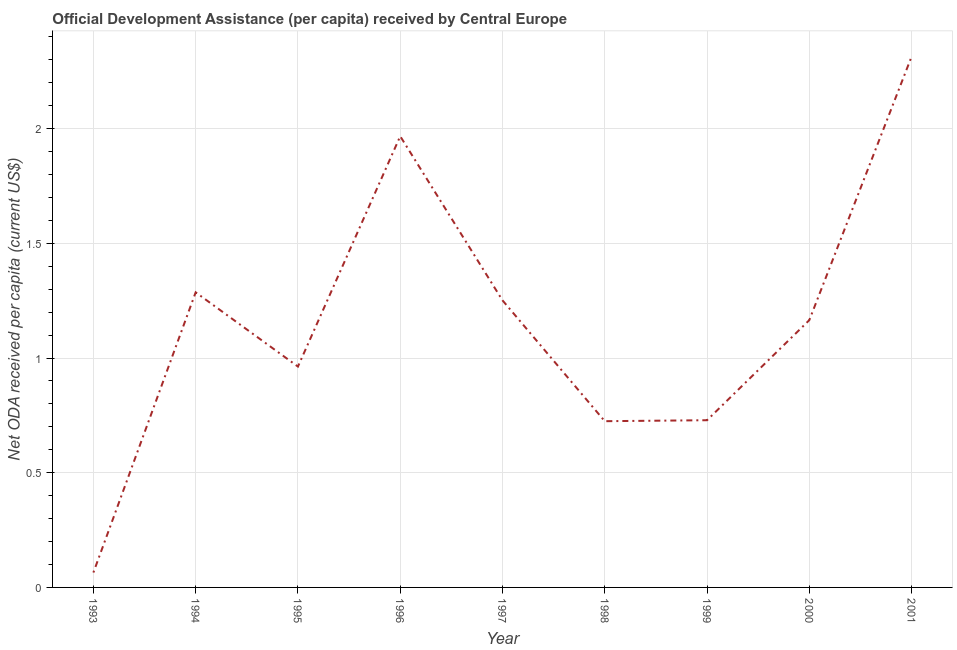What is the net oda received per capita in 2001?
Provide a short and direct response. 2.31. Across all years, what is the maximum net oda received per capita?
Offer a very short reply. 2.31. Across all years, what is the minimum net oda received per capita?
Provide a short and direct response. 0.06. In which year was the net oda received per capita maximum?
Your response must be concise. 2001. In which year was the net oda received per capita minimum?
Provide a short and direct response. 1993. What is the sum of the net oda received per capita?
Keep it short and to the point. 10.47. What is the difference between the net oda received per capita in 1997 and 2000?
Ensure brevity in your answer.  0.09. What is the average net oda received per capita per year?
Offer a terse response. 1.16. What is the median net oda received per capita?
Offer a very short reply. 1.17. In how many years, is the net oda received per capita greater than 0.2 US$?
Provide a succinct answer. 8. What is the ratio of the net oda received per capita in 1996 to that in 1997?
Provide a short and direct response. 1.57. Is the net oda received per capita in 1994 less than that in 1995?
Keep it short and to the point. No. Is the difference between the net oda received per capita in 1996 and 1998 greater than the difference between any two years?
Give a very brief answer. No. What is the difference between the highest and the second highest net oda received per capita?
Offer a very short reply. 0.35. What is the difference between the highest and the lowest net oda received per capita?
Make the answer very short. 2.25. How many years are there in the graph?
Make the answer very short. 9. Are the values on the major ticks of Y-axis written in scientific E-notation?
Ensure brevity in your answer.  No. Does the graph contain any zero values?
Your response must be concise. No. What is the title of the graph?
Offer a terse response. Official Development Assistance (per capita) received by Central Europe. What is the label or title of the X-axis?
Make the answer very short. Year. What is the label or title of the Y-axis?
Make the answer very short. Net ODA received per capita (current US$). What is the Net ODA received per capita (current US$) in 1993?
Give a very brief answer. 0.06. What is the Net ODA received per capita (current US$) in 1994?
Offer a terse response. 1.29. What is the Net ODA received per capita (current US$) in 1995?
Your response must be concise. 0.96. What is the Net ODA received per capita (current US$) in 1996?
Give a very brief answer. 1.97. What is the Net ODA received per capita (current US$) in 1997?
Your response must be concise. 1.25. What is the Net ODA received per capita (current US$) in 1998?
Your answer should be compact. 0.72. What is the Net ODA received per capita (current US$) in 1999?
Your response must be concise. 0.73. What is the Net ODA received per capita (current US$) in 2000?
Your answer should be very brief. 1.17. What is the Net ODA received per capita (current US$) in 2001?
Your answer should be very brief. 2.31. What is the difference between the Net ODA received per capita (current US$) in 1993 and 1994?
Offer a very short reply. -1.22. What is the difference between the Net ODA received per capita (current US$) in 1993 and 1995?
Provide a succinct answer. -0.9. What is the difference between the Net ODA received per capita (current US$) in 1993 and 1996?
Give a very brief answer. -1.9. What is the difference between the Net ODA received per capita (current US$) in 1993 and 1997?
Provide a short and direct response. -1.19. What is the difference between the Net ODA received per capita (current US$) in 1993 and 1998?
Ensure brevity in your answer.  -0.66. What is the difference between the Net ODA received per capita (current US$) in 1993 and 1999?
Keep it short and to the point. -0.66. What is the difference between the Net ODA received per capita (current US$) in 1993 and 2000?
Give a very brief answer. -1.1. What is the difference between the Net ODA received per capita (current US$) in 1993 and 2001?
Offer a terse response. -2.25. What is the difference between the Net ODA received per capita (current US$) in 1994 and 1995?
Make the answer very short. 0.32. What is the difference between the Net ODA received per capita (current US$) in 1994 and 1996?
Offer a very short reply. -0.68. What is the difference between the Net ODA received per capita (current US$) in 1994 and 1997?
Your answer should be very brief. 0.03. What is the difference between the Net ODA received per capita (current US$) in 1994 and 1998?
Provide a succinct answer. 0.56. What is the difference between the Net ODA received per capita (current US$) in 1994 and 1999?
Your answer should be very brief. 0.56. What is the difference between the Net ODA received per capita (current US$) in 1994 and 2000?
Provide a succinct answer. 0.12. What is the difference between the Net ODA received per capita (current US$) in 1994 and 2001?
Offer a very short reply. -1.03. What is the difference between the Net ODA received per capita (current US$) in 1995 and 1996?
Make the answer very short. -1. What is the difference between the Net ODA received per capita (current US$) in 1995 and 1997?
Your response must be concise. -0.29. What is the difference between the Net ODA received per capita (current US$) in 1995 and 1998?
Your response must be concise. 0.24. What is the difference between the Net ODA received per capita (current US$) in 1995 and 1999?
Your response must be concise. 0.23. What is the difference between the Net ODA received per capita (current US$) in 1995 and 2000?
Offer a very short reply. -0.2. What is the difference between the Net ODA received per capita (current US$) in 1995 and 2001?
Keep it short and to the point. -1.35. What is the difference between the Net ODA received per capita (current US$) in 1996 and 1997?
Keep it short and to the point. 0.72. What is the difference between the Net ODA received per capita (current US$) in 1996 and 1998?
Provide a succinct answer. 1.24. What is the difference between the Net ODA received per capita (current US$) in 1996 and 1999?
Your answer should be compact. 1.24. What is the difference between the Net ODA received per capita (current US$) in 1996 and 2000?
Your response must be concise. 0.8. What is the difference between the Net ODA received per capita (current US$) in 1996 and 2001?
Keep it short and to the point. -0.35. What is the difference between the Net ODA received per capita (current US$) in 1997 and 1998?
Provide a short and direct response. 0.53. What is the difference between the Net ODA received per capita (current US$) in 1997 and 1999?
Provide a short and direct response. 0.52. What is the difference between the Net ODA received per capita (current US$) in 1997 and 2000?
Ensure brevity in your answer.  0.09. What is the difference between the Net ODA received per capita (current US$) in 1997 and 2001?
Provide a succinct answer. -1.06. What is the difference between the Net ODA received per capita (current US$) in 1998 and 1999?
Offer a terse response. -0. What is the difference between the Net ODA received per capita (current US$) in 1998 and 2000?
Offer a terse response. -0.44. What is the difference between the Net ODA received per capita (current US$) in 1998 and 2001?
Make the answer very short. -1.59. What is the difference between the Net ODA received per capita (current US$) in 1999 and 2000?
Keep it short and to the point. -0.44. What is the difference between the Net ODA received per capita (current US$) in 1999 and 2001?
Offer a terse response. -1.59. What is the difference between the Net ODA received per capita (current US$) in 2000 and 2001?
Offer a terse response. -1.15. What is the ratio of the Net ODA received per capita (current US$) in 1993 to that in 1994?
Provide a succinct answer. 0.05. What is the ratio of the Net ODA received per capita (current US$) in 1993 to that in 1995?
Your answer should be very brief. 0.07. What is the ratio of the Net ODA received per capita (current US$) in 1993 to that in 1996?
Ensure brevity in your answer.  0.03. What is the ratio of the Net ODA received per capita (current US$) in 1993 to that in 1997?
Ensure brevity in your answer.  0.05. What is the ratio of the Net ODA received per capita (current US$) in 1993 to that in 1998?
Give a very brief answer. 0.09. What is the ratio of the Net ODA received per capita (current US$) in 1993 to that in 1999?
Make the answer very short. 0.09. What is the ratio of the Net ODA received per capita (current US$) in 1993 to that in 2000?
Offer a terse response. 0.06. What is the ratio of the Net ODA received per capita (current US$) in 1993 to that in 2001?
Provide a succinct answer. 0.03. What is the ratio of the Net ODA received per capita (current US$) in 1994 to that in 1995?
Ensure brevity in your answer.  1.34. What is the ratio of the Net ODA received per capita (current US$) in 1994 to that in 1996?
Offer a terse response. 0.65. What is the ratio of the Net ODA received per capita (current US$) in 1994 to that in 1997?
Keep it short and to the point. 1.03. What is the ratio of the Net ODA received per capita (current US$) in 1994 to that in 1998?
Make the answer very short. 1.77. What is the ratio of the Net ODA received per capita (current US$) in 1994 to that in 1999?
Provide a succinct answer. 1.76. What is the ratio of the Net ODA received per capita (current US$) in 1994 to that in 2000?
Your response must be concise. 1.1. What is the ratio of the Net ODA received per capita (current US$) in 1994 to that in 2001?
Make the answer very short. 0.56. What is the ratio of the Net ODA received per capita (current US$) in 1995 to that in 1996?
Your answer should be compact. 0.49. What is the ratio of the Net ODA received per capita (current US$) in 1995 to that in 1997?
Your answer should be compact. 0.77. What is the ratio of the Net ODA received per capita (current US$) in 1995 to that in 1998?
Provide a succinct answer. 1.33. What is the ratio of the Net ODA received per capita (current US$) in 1995 to that in 1999?
Offer a very short reply. 1.32. What is the ratio of the Net ODA received per capita (current US$) in 1995 to that in 2000?
Your answer should be very brief. 0.83. What is the ratio of the Net ODA received per capita (current US$) in 1995 to that in 2001?
Your answer should be very brief. 0.42. What is the ratio of the Net ODA received per capita (current US$) in 1996 to that in 1997?
Your response must be concise. 1.57. What is the ratio of the Net ODA received per capita (current US$) in 1996 to that in 1998?
Ensure brevity in your answer.  2.71. What is the ratio of the Net ODA received per capita (current US$) in 1996 to that in 1999?
Give a very brief answer. 2.7. What is the ratio of the Net ODA received per capita (current US$) in 1996 to that in 2000?
Ensure brevity in your answer.  1.69. What is the ratio of the Net ODA received per capita (current US$) in 1997 to that in 1998?
Your answer should be very brief. 1.73. What is the ratio of the Net ODA received per capita (current US$) in 1997 to that in 1999?
Your answer should be very brief. 1.72. What is the ratio of the Net ODA received per capita (current US$) in 1997 to that in 2000?
Offer a very short reply. 1.07. What is the ratio of the Net ODA received per capita (current US$) in 1997 to that in 2001?
Your response must be concise. 0.54. What is the ratio of the Net ODA received per capita (current US$) in 1998 to that in 1999?
Your response must be concise. 0.99. What is the ratio of the Net ODA received per capita (current US$) in 1998 to that in 2000?
Your answer should be very brief. 0.62. What is the ratio of the Net ODA received per capita (current US$) in 1998 to that in 2001?
Offer a very short reply. 0.31. What is the ratio of the Net ODA received per capita (current US$) in 1999 to that in 2000?
Your answer should be compact. 0.63. What is the ratio of the Net ODA received per capita (current US$) in 1999 to that in 2001?
Make the answer very short. 0.32. What is the ratio of the Net ODA received per capita (current US$) in 2000 to that in 2001?
Ensure brevity in your answer.  0.5. 